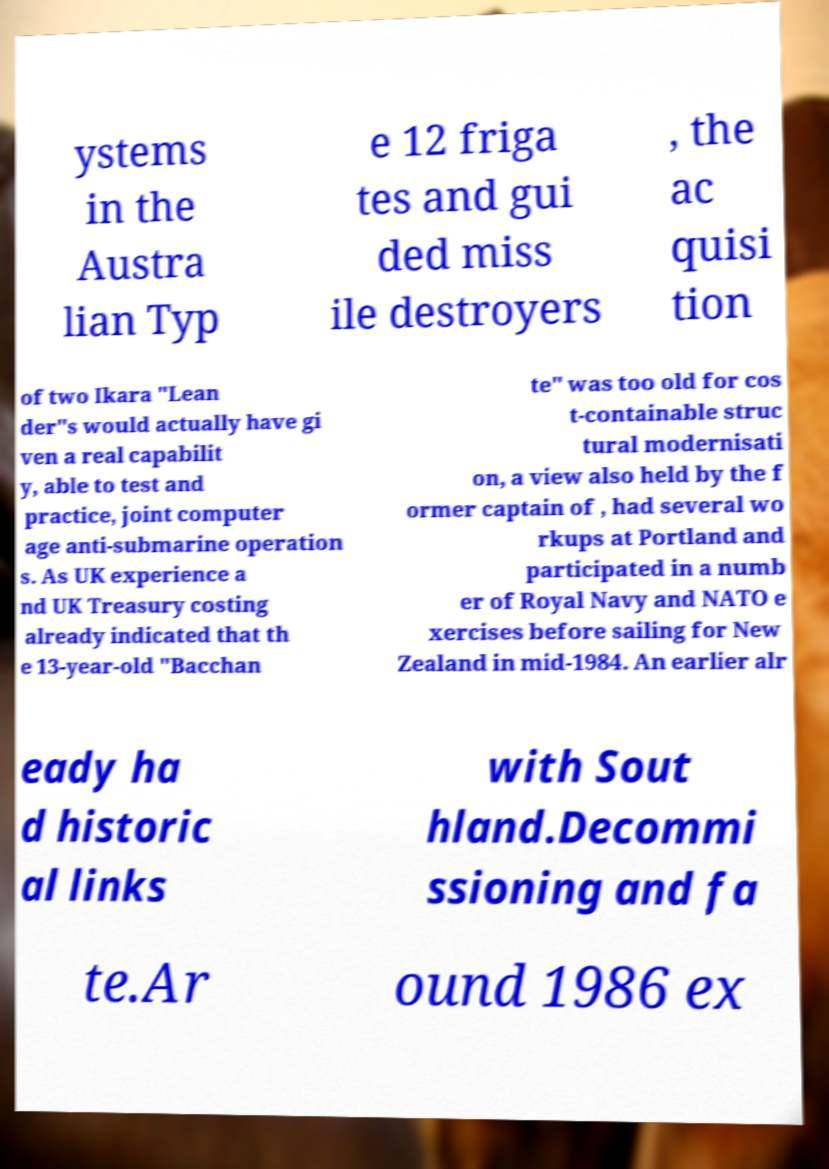Could you assist in decoding the text presented in this image and type it out clearly? ystems in the Austra lian Typ e 12 friga tes and gui ded miss ile destroyers , the ac quisi tion of two Ikara "Lean der"s would actually have gi ven a real capabilit y, able to test and practice, joint computer age anti-submarine operation s. As UK experience a nd UK Treasury costing already indicated that th e 13-year-old "Bacchan te" was too old for cos t-containable struc tural modernisati on, a view also held by the f ormer captain of , had several wo rkups at Portland and participated in a numb er of Royal Navy and NATO e xercises before sailing for New Zealand in mid-1984. An earlier alr eady ha d historic al links with Sout hland.Decommi ssioning and fa te.Ar ound 1986 ex 